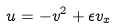<formula> <loc_0><loc_0><loc_500><loc_500>u = - v ^ { 2 } + \epsilon v _ { x }</formula> 